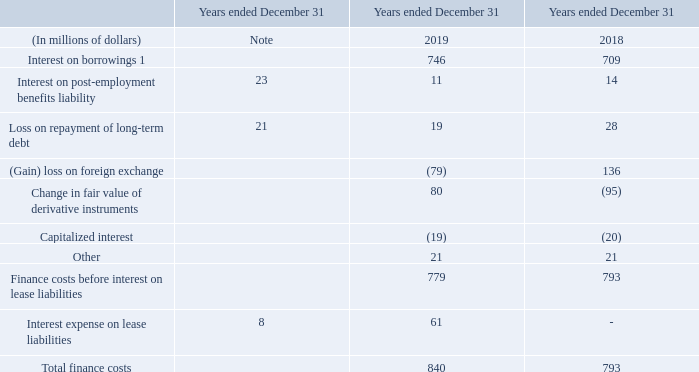1 Interest on borrowings includes interest on short-term borrowings and on long-term debt.
FOREIGN EXCHANGE AND CHANGE IN FAIR VALUE OF DERIVATIVE INSTRUMENTS We recognized $79 million in net foreign exchange gains in 2019 (2018 – $136 million in net losses). These gains and losses were primarily attributed to our US dollar-denominated commercial paper (US CP) program borrowings (see note 17).
These foreign exchange gains (2018 – losses) were partially offset by the $80 million loss related to the change in fair value of derivatives (2018 – $95 million gain) that was primarily attributed to the debt derivatives, which were not designated as hedges for accounting purposes, we used to substantially offset the foreign exchange risk related to these US dollar-denominated borrowings.
During the year ended December 31, 2018, after determining we would not be able to exercise our outstanding bond forward derivatives (bond forwards) within the designated time frame, we discontinued hedge accounting and reclassified a $21 million loss from the hedging reserve within shareholders’ equity to “change in fair value of derivative instruments” within finance costs.
We subsequently extended the bond forwards and redesignated them as effective hedges. During the year ended December 31, 2019, we exercised these bond forwards. See note 17 for more information on our bond forwards.
NOTE 11: FINANCE COSTS
What is included in the Interest on borrowings? Interest on borrowings includes interest on short-term borrowings and on long-term debt. What is attributed as change in fair value of derivatives? Primarily attributed to the debt derivatives, which were not designated as hedges for accounting purposes, we used to substantially offset the foreign exchange risk related to these us dollar-denominated borrowings. How much was the net foreign exchange gains in 2019? $79 million in net foreign exchange gains in 2019. What is the increase/ (decrease) in Interest on borrowings from 2018 to 2019?
Answer scale should be: million. 746-709
Answer: 37. What is the increase/ (decrease) in Interest on post-employment benefits liability from 2018 to 2019?
Answer scale should be: million. 11-14
Answer: -3. What is the increase/ (decrease) in Loss on repayment of long-term debt from 2018 to 2019?
Answer scale should be: million. 19-28
Answer: -9. 